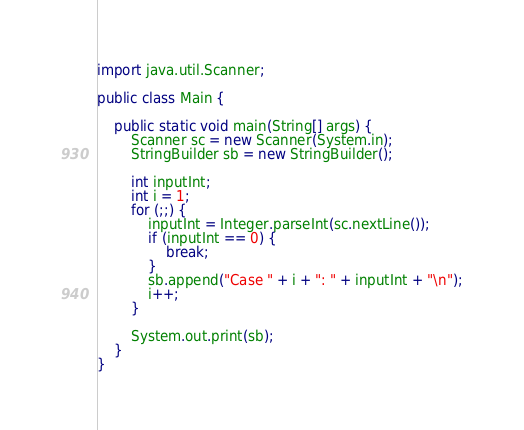Convert code to text. <code><loc_0><loc_0><loc_500><loc_500><_Java_>import java.util.Scanner;

public class Main {

    public static void main(String[] args) {
        Scanner sc = new Scanner(System.in);
        StringBuilder sb = new StringBuilder();

        int inputInt;
        int i = 1;
        for (;;) {
            inputInt = Integer.parseInt(sc.nextLine());
            if (inputInt == 0) {
                break;
            }
            sb.append("Case " + i + ": " + inputInt + "\n");
            i++;
        }

        System.out.print(sb);
    }
}</code> 